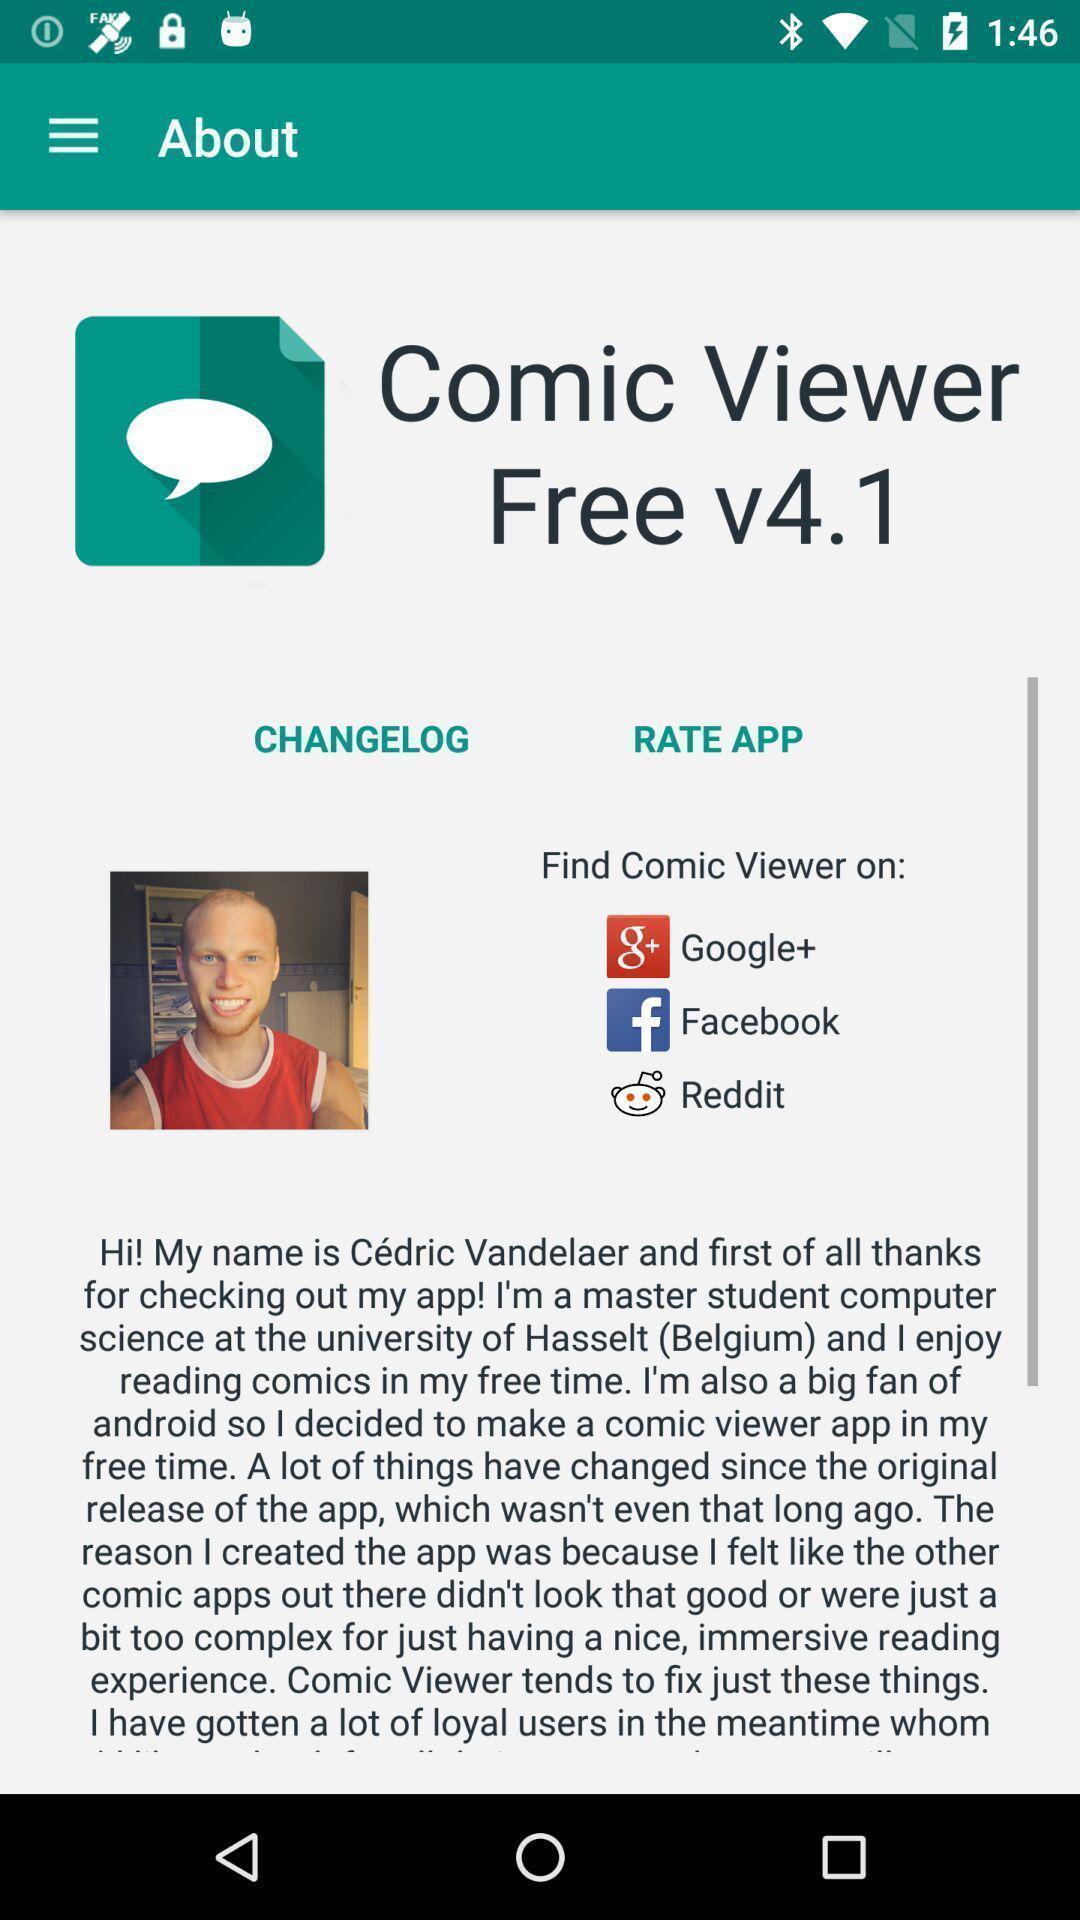What is the overall content of this screenshot? Page shows options of changelog and rating on social app. 